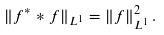Convert formula to latex. <formula><loc_0><loc_0><loc_500><loc_500>\| f ^ { * } * f \| _ { L ^ { 1 } } = \| f \| _ { L ^ { 1 } } ^ { 2 } \, . \\</formula> 